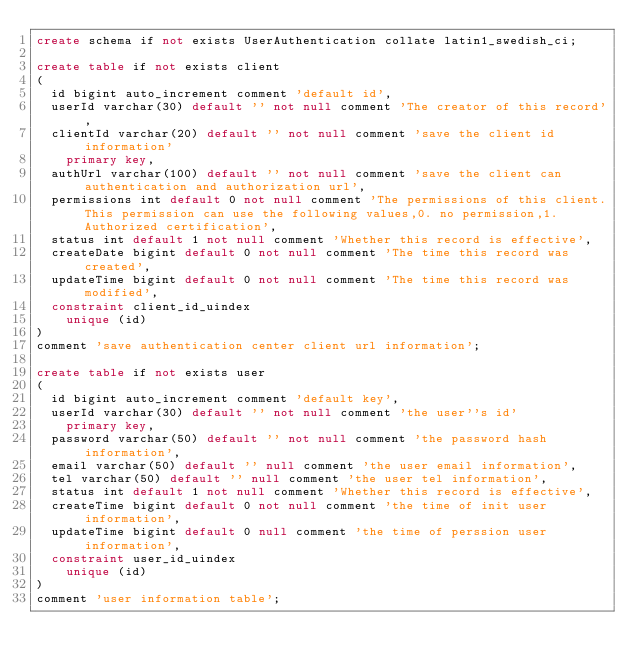Convert code to text. <code><loc_0><loc_0><loc_500><loc_500><_SQL_>create schema if not exists UserAuthentication collate latin1_swedish_ci;

create table if not exists client
(
	id bigint auto_increment comment 'default id',
	userId varchar(30) default '' not null comment 'The creator of this record',
	clientId varchar(20) default '' not null comment 'save the client id information'
		primary key,
	authUrl varchar(100) default '' not null comment 'save the client can authentication and authorization url',
	permissions int default 0 not null comment 'The permissions of this client.This permission can use the following values,0. no permission,1. Authorized certification',
	status int default 1 not null comment 'Whether this record is effective',
	createDate bigint default 0 not null comment 'The time this record was created',
	updateTime bigint default 0 not null comment 'The time this record was modified',
	constraint client_id_uindex
		unique (id)
)
comment 'save authentication center client url information';

create table if not exists user
(
	id bigint auto_increment comment 'default key',
	userId varchar(30) default '' not null comment 'the user''s id'
		primary key,
	password varchar(50) default '' not null comment 'the password hash information',
	email varchar(50) default '' null comment 'the user email information',
	tel varchar(50) default '' null comment 'the user tel information',
	status int default 1 not null comment 'Whether this record is effective',
	createTime bigint default 0 not null comment 'the time of init user information',
	updateTime bigint default 0 null comment 'the time of perssion user information',
	constraint user_id_uindex
		unique (id)
)
comment 'user information table';

</code> 